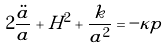Convert formula to latex. <formula><loc_0><loc_0><loc_500><loc_500>2 \frac { \ddot { a } } { a } + H ^ { 2 } + \frac { k } { a ^ { 2 } } = - \kappa p</formula> 